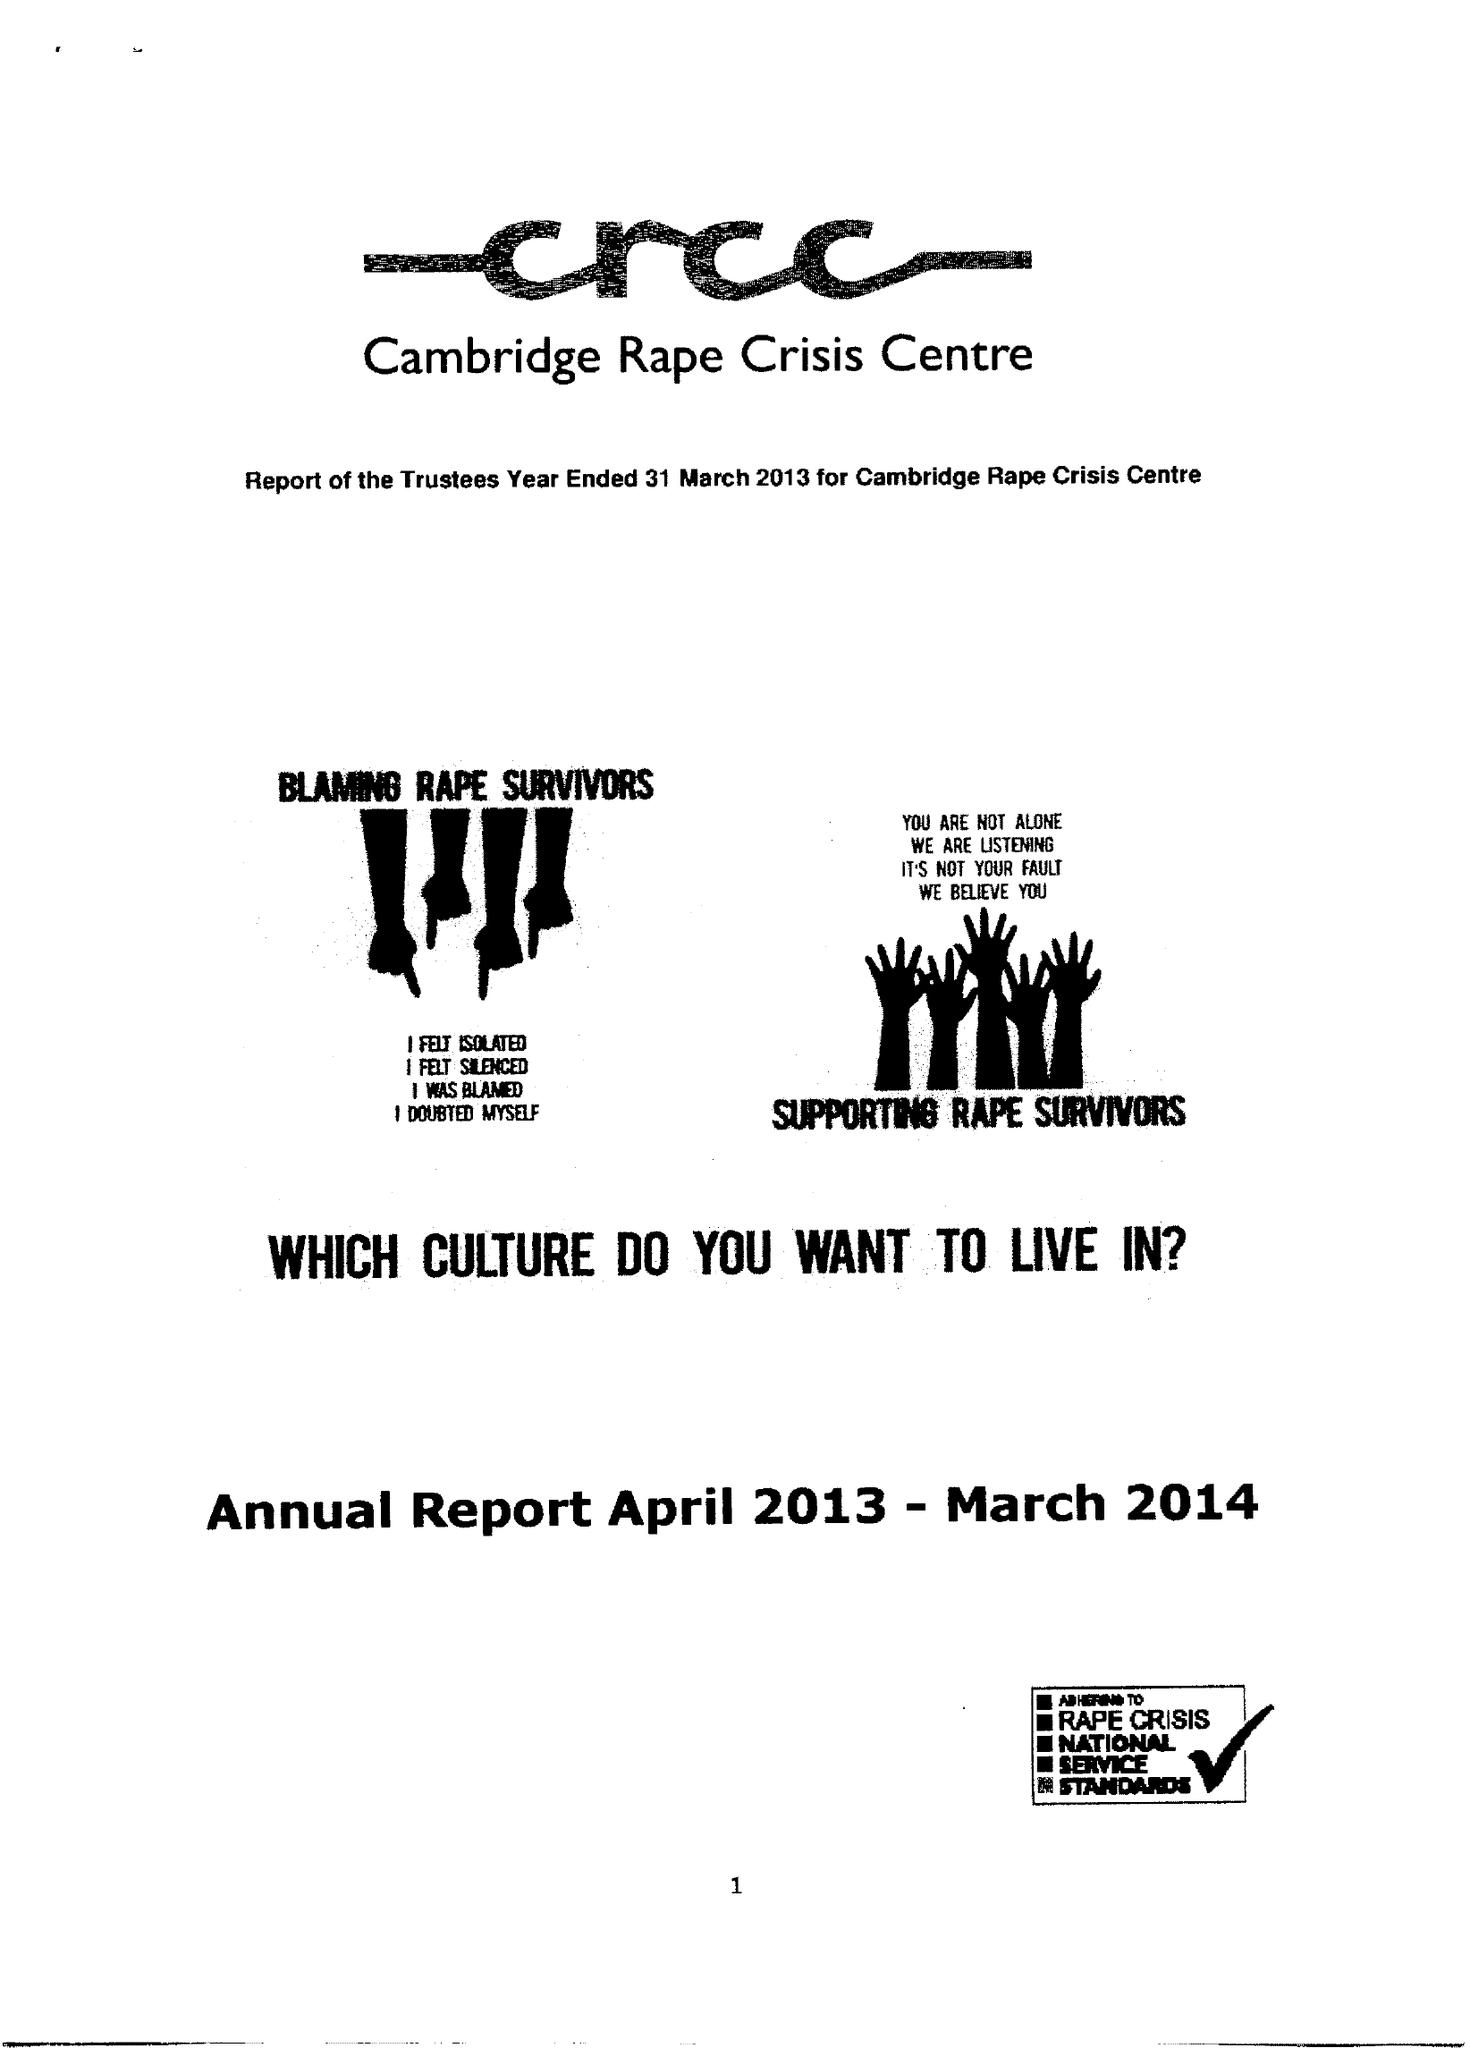What is the value for the address__street_line?
Answer the question using a single word or phrase. 12 MILL ROAD 